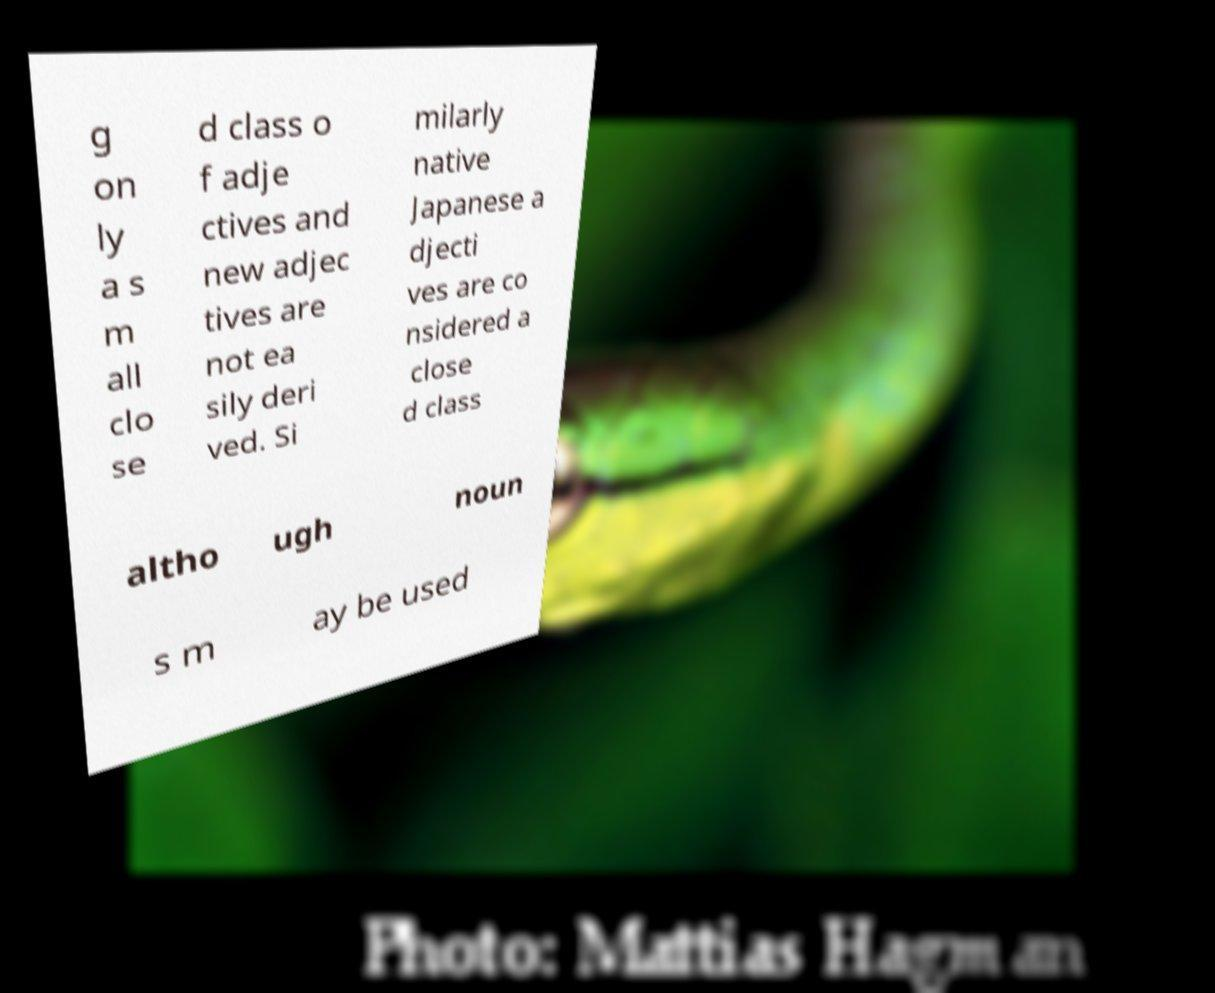Please read and relay the text visible in this image. What does it say? g on ly a s m all clo se d class o f adje ctives and new adjec tives are not ea sily deri ved. Si milarly native Japanese a djecti ves are co nsidered a close d class altho ugh noun s m ay be used 